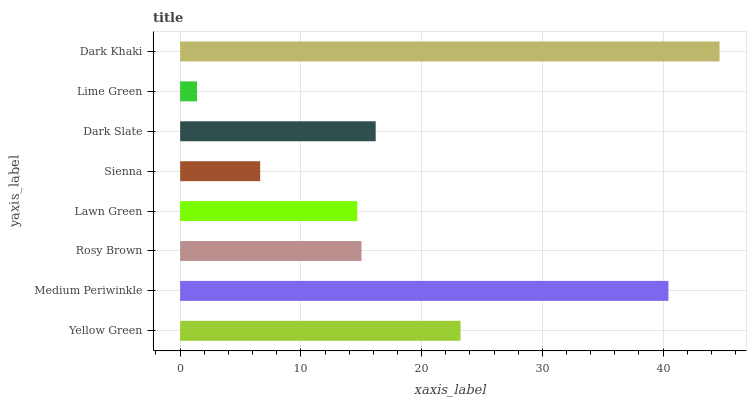Is Lime Green the minimum?
Answer yes or no. Yes. Is Dark Khaki the maximum?
Answer yes or no. Yes. Is Medium Periwinkle the minimum?
Answer yes or no. No. Is Medium Periwinkle the maximum?
Answer yes or no. No. Is Medium Periwinkle greater than Yellow Green?
Answer yes or no. Yes. Is Yellow Green less than Medium Periwinkle?
Answer yes or no. Yes. Is Yellow Green greater than Medium Periwinkle?
Answer yes or no. No. Is Medium Periwinkle less than Yellow Green?
Answer yes or no. No. Is Dark Slate the high median?
Answer yes or no. Yes. Is Rosy Brown the low median?
Answer yes or no. Yes. Is Medium Periwinkle the high median?
Answer yes or no. No. Is Sienna the low median?
Answer yes or no. No. 